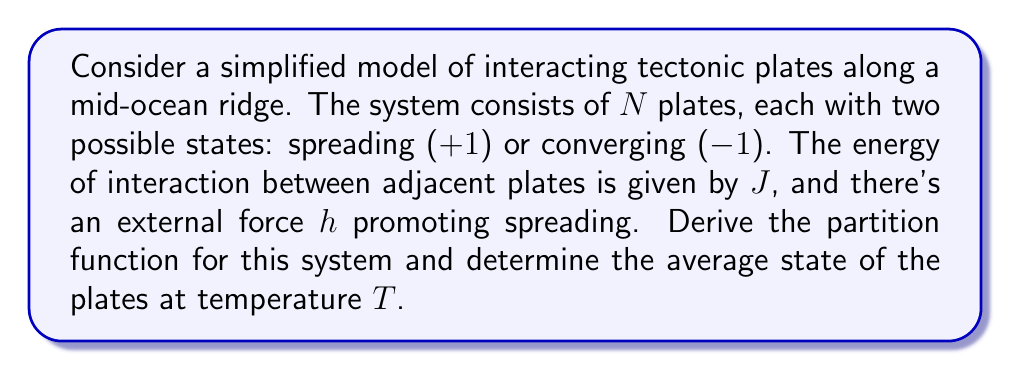Give your solution to this math problem. 1. First, we need to define the Hamiltonian of the system. For a 1D chain of plates:

   $$H = -J\sum_{i=1}^{N-1} s_i s_{i+1} - h\sum_{i=1}^N s_i$$

   where $s_i = \pm 1$ represents the state of each plate.

2. The partition function is given by:

   $$Z = \sum_{\{s_i\}} e^{-\beta H}$$

   where $\beta = \frac{1}{k_B T}$, $k_B$ is the Boltzmann constant, and the sum is over all possible configurations.

3. This system is analogous to the 1D Ising model. The exact solution for the partition function is:

   $$Z = \lambda_+^N + \lambda_-^N$$

   where $\lambda_{\pm}$ are the eigenvalues of the transfer matrix:

   $$\lambda_{\pm} = e^{\beta J} \cosh(\beta h) \pm \sqrt{e^{2\beta J} \sinh^2(\beta h) + e^{-2\beta J}}$$

4. The average state of the plates (magnetization in Ising model terms) is given by:

   $$\langle s \rangle = \frac{1}{N} \frac{\partial \ln Z}{\partial (\beta h)}$$

5. Substituting the partition function and differentiating:

   $$\langle s \rangle = \frac{\lambda_+^N \frac{\partial \lambda_+}{\partial (\beta h)} + \lambda_-^N \frac{\partial \lambda_-}{\partial (\beta h)}}{\lambda_+^N + \lambda_-^N}$$

6. In the thermodynamic limit (N → ∞), only the larger eigenvalue contributes:

   $$\langle s \rangle = \frac{1}{\lambda_+} \frac{\partial \lambda_+}{\partial (\beta h)} = \frac{\sinh(\beta h)}{\sqrt{\sinh^2(\beta h) + e^{-4\beta J}}}$$

This expression gives the average state of the plates as a function of temperature, interaction strength, and external force.
Answer: $\langle s \rangle = \frac{\sinh(\beta h)}{\sqrt{\sinh^2(\beta h) + e^{-4\beta J}}}$ 